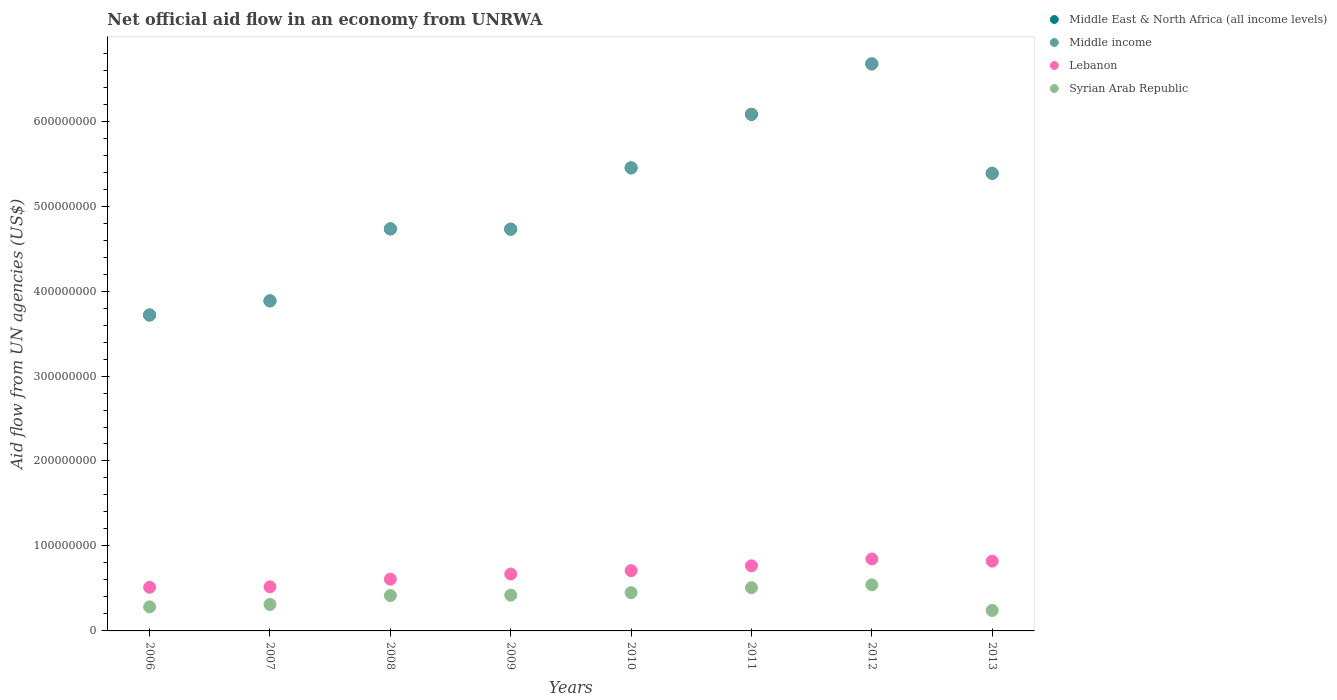Is the number of dotlines equal to the number of legend labels?
Provide a succinct answer. Yes. What is the net official aid flow in Middle East & North Africa (all income levels) in 2011?
Ensure brevity in your answer.  6.08e+08. Across all years, what is the maximum net official aid flow in Lebanon?
Ensure brevity in your answer.  8.47e+07. Across all years, what is the minimum net official aid flow in Syrian Arab Republic?
Your answer should be compact. 2.41e+07. What is the total net official aid flow in Lebanon in the graph?
Your answer should be very brief. 5.46e+08. What is the difference between the net official aid flow in Syrian Arab Republic in 2006 and that in 2011?
Your answer should be very brief. -2.26e+07. What is the difference between the net official aid flow in Middle East & North Africa (all income levels) in 2007 and the net official aid flow in Syrian Arab Republic in 2008?
Offer a very short reply. 3.47e+08. What is the average net official aid flow in Middle East & North Africa (all income levels) per year?
Offer a very short reply. 5.08e+08. In the year 2013, what is the difference between the net official aid flow in Lebanon and net official aid flow in Middle East & North Africa (all income levels)?
Give a very brief answer. -4.57e+08. In how many years, is the net official aid flow in Lebanon greater than 260000000 US$?
Your answer should be very brief. 0. What is the ratio of the net official aid flow in Middle income in 2010 to that in 2011?
Your response must be concise. 0.9. Is the difference between the net official aid flow in Lebanon in 2010 and 2011 greater than the difference between the net official aid flow in Middle East & North Africa (all income levels) in 2010 and 2011?
Your response must be concise. Yes. What is the difference between the highest and the second highest net official aid flow in Middle East & North Africa (all income levels)?
Offer a very short reply. 5.94e+07. What is the difference between the highest and the lowest net official aid flow in Syrian Arab Republic?
Offer a terse response. 3.02e+07. Is it the case that in every year, the sum of the net official aid flow in Middle East & North Africa (all income levels) and net official aid flow in Middle income  is greater than the net official aid flow in Syrian Arab Republic?
Keep it short and to the point. Yes. Is the net official aid flow in Middle East & North Africa (all income levels) strictly less than the net official aid flow in Lebanon over the years?
Provide a short and direct response. No. How many years are there in the graph?
Provide a short and direct response. 8. What is the difference between two consecutive major ticks on the Y-axis?
Offer a very short reply. 1.00e+08. Are the values on the major ticks of Y-axis written in scientific E-notation?
Make the answer very short. No. Does the graph contain any zero values?
Offer a terse response. No. Does the graph contain grids?
Make the answer very short. No. How many legend labels are there?
Provide a short and direct response. 4. What is the title of the graph?
Ensure brevity in your answer.  Net official aid flow in an economy from UNRWA. Does "Chile" appear as one of the legend labels in the graph?
Ensure brevity in your answer.  No. What is the label or title of the Y-axis?
Offer a terse response. Aid flow from UN agencies (US$). What is the Aid flow from UN agencies (US$) in Middle East & North Africa (all income levels) in 2006?
Your response must be concise. 3.72e+08. What is the Aid flow from UN agencies (US$) in Middle income in 2006?
Offer a very short reply. 3.72e+08. What is the Aid flow from UN agencies (US$) in Lebanon in 2006?
Ensure brevity in your answer.  5.14e+07. What is the Aid flow from UN agencies (US$) in Syrian Arab Republic in 2006?
Make the answer very short. 2.83e+07. What is the Aid flow from UN agencies (US$) in Middle East & North Africa (all income levels) in 2007?
Give a very brief answer. 3.88e+08. What is the Aid flow from UN agencies (US$) in Middle income in 2007?
Keep it short and to the point. 3.88e+08. What is the Aid flow from UN agencies (US$) of Lebanon in 2007?
Your answer should be compact. 5.19e+07. What is the Aid flow from UN agencies (US$) of Syrian Arab Republic in 2007?
Make the answer very short. 3.12e+07. What is the Aid flow from UN agencies (US$) in Middle East & North Africa (all income levels) in 2008?
Keep it short and to the point. 4.73e+08. What is the Aid flow from UN agencies (US$) of Middle income in 2008?
Provide a succinct answer. 4.73e+08. What is the Aid flow from UN agencies (US$) in Lebanon in 2008?
Ensure brevity in your answer.  6.09e+07. What is the Aid flow from UN agencies (US$) in Syrian Arab Republic in 2008?
Provide a succinct answer. 4.16e+07. What is the Aid flow from UN agencies (US$) in Middle East & North Africa (all income levels) in 2009?
Offer a terse response. 4.73e+08. What is the Aid flow from UN agencies (US$) in Middle income in 2009?
Your response must be concise. 4.73e+08. What is the Aid flow from UN agencies (US$) of Lebanon in 2009?
Give a very brief answer. 6.70e+07. What is the Aid flow from UN agencies (US$) of Syrian Arab Republic in 2009?
Make the answer very short. 4.21e+07. What is the Aid flow from UN agencies (US$) in Middle East & North Africa (all income levels) in 2010?
Your answer should be compact. 5.45e+08. What is the Aid flow from UN agencies (US$) in Middle income in 2010?
Ensure brevity in your answer.  5.45e+08. What is the Aid flow from UN agencies (US$) of Lebanon in 2010?
Ensure brevity in your answer.  7.10e+07. What is the Aid flow from UN agencies (US$) of Syrian Arab Republic in 2010?
Give a very brief answer. 4.50e+07. What is the Aid flow from UN agencies (US$) in Middle East & North Africa (all income levels) in 2011?
Your answer should be very brief. 6.08e+08. What is the Aid flow from UN agencies (US$) in Middle income in 2011?
Make the answer very short. 6.08e+08. What is the Aid flow from UN agencies (US$) in Lebanon in 2011?
Offer a very short reply. 7.66e+07. What is the Aid flow from UN agencies (US$) in Syrian Arab Republic in 2011?
Your answer should be compact. 5.09e+07. What is the Aid flow from UN agencies (US$) of Middle East & North Africa (all income levels) in 2012?
Offer a terse response. 6.67e+08. What is the Aid flow from UN agencies (US$) of Middle income in 2012?
Give a very brief answer. 6.67e+08. What is the Aid flow from UN agencies (US$) of Lebanon in 2012?
Offer a terse response. 8.47e+07. What is the Aid flow from UN agencies (US$) in Syrian Arab Republic in 2012?
Make the answer very short. 5.42e+07. What is the Aid flow from UN agencies (US$) in Middle East & North Africa (all income levels) in 2013?
Keep it short and to the point. 5.39e+08. What is the Aid flow from UN agencies (US$) of Middle income in 2013?
Provide a succinct answer. 5.39e+08. What is the Aid flow from UN agencies (US$) in Lebanon in 2013?
Give a very brief answer. 8.21e+07. What is the Aid flow from UN agencies (US$) of Syrian Arab Republic in 2013?
Provide a succinct answer. 2.41e+07. Across all years, what is the maximum Aid flow from UN agencies (US$) of Middle East & North Africa (all income levels)?
Provide a short and direct response. 6.67e+08. Across all years, what is the maximum Aid flow from UN agencies (US$) in Middle income?
Your response must be concise. 6.67e+08. Across all years, what is the maximum Aid flow from UN agencies (US$) in Lebanon?
Give a very brief answer. 8.47e+07. Across all years, what is the maximum Aid flow from UN agencies (US$) in Syrian Arab Republic?
Make the answer very short. 5.42e+07. Across all years, what is the minimum Aid flow from UN agencies (US$) of Middle East & North Africa (all income levels)?
Ensure brevity in your answer.  3.72e+08. Across all years, what is the minimum Aid flow from UN agencies (US$) of Middle income?
Give a very brief answer. 3.72e+08. Across all years, what is the minimum Aid flow from UN agencies (US$) in Lebanon?
Your response must be concise. 5.14e+07. Across all years, what is the minimum Aid flow from UN agencies (US$) of Syrian Arab Republic?
Provide a short and direct response. 2.41e+07. What is the total Aid flow from UN agencies (US$) in Middle East & North Africa (all income levels) in the graph?
Keep it short and to the point. 4.07e+09. What is the total Aid flow from UN agencies (US$) in Middle income in the graph?
Offer a terse response. 4.07e+09. What is the total Aid flow from UN agencies (US$) of Lebanon in the graph?
Offer a very short reply. 5.46e+08. What is the total Aid flow from UN agencies (US$) in Syrian Arab Republic in the graph?
Keep it short and to the point. 3.18e+08. What is the difference between the Aid flow from UN agencies (US$) in Middle East & North Africa (all income levels) in 2006 and that in 2007?
Ensure brevity in your answer.  -1.66e+07. What is the difference between the Aid flow from UN agencies (US$) of Middle income in 2006 and that in 2007?
Your response must be concise. -1.66e+07. What is the difference between the Aid flow from UN agencies (US$) in Lebanon in 2006 and that in 2007?
Offer a terse response. -5.30e+05. What is the difference between the Aid flow from UN agencies (US$) in Syrian Arab Republic in 2006 and that in 2007?
Make the answer very short. -2.83e+06. What is the difference between the Aid flow from UN agencies (US$) of Middle East & North Africa (all income levels) in 2006 and that in 2008?
Your answer should be very brief. -1.01e+08. What is the difference between the Aid flow from UN agencies (US$) in Middle income in 2006 and that in 2008?
Offer a very short reply. -1.01e+08. What is the difference between the Aid flow from UN agencies (US$) of Lebanon in 2006 and that in 2008?
Your response must be concise. -9.54e+06. What is the difference between the Aid flow from UN agencies (US$) of Syrian Arab Republic in 2006 and that in 2008?
Make the answer very short. -1.33e+07. What is the difference between the Aid flow from UN agencies (US$) of Middle East & North Africa (all income levels) in 2006 and that in 2009?
Keep it short and to the point. -1.01e+08. What is the difference between the Aid flow from UN agencies (US$) of Middle income in 2006 and that in 2009?
Offer a very short reply. -1.01e+08. What is the difference between the Aid flow from UN agencies (US$) of Lebanon in 2006 and that in 2009?
Keep it short and to the point. -1.56e+07. What is the difference between the Aid flow from UN agencies (US$) in Syrian Arab Republic in 2006 and that in 2009?
Ensure brevity in your answer.  -1.38e+07. What is the difference between the Aid flow from UN agencies (US$) of Middle East & North Africa (all income levels) in 2006 and that in 2010?
Your response must be concise. -1.73e+08. What is the difference between the Aid flow from UN agencies (US$) in Middle income in 2006 and that in 2010?
Your answer should be compact. -1.73e+08. What is the difference between the Aid flow from UN agencies (US$) in Lebanon in 2006 and that in 2010?
Your answer should be compact. -1.96e+07. What is the difference between the Aid flow from UN agencies (US$) in Syrian Arab Republic in 2006 and that in 2010?
Make the answer very short. -1.67e+07. What is the difference between the Aid flow from UN agencies (US$) of Middle East & North Africa (all income levels) in 2006 and that in 2011?
Give a very brief answer. -2.36e+08. What is the difference between the Aid flow from UN agencies (US$) in Middle income in 2006 and that in 2011?
Offer a very short reply. -2.36e+08. What is the difference between the Aid flow from UN agencies (US$) of Lebanon in 2006 and that in 2011?
Give a very brief answer. -2.53e+07. What is the difference between the Aid flow from UN agencies (US$) of Syrian Arab Republic in 2006 and that in 2011?
Offer a very short reply. -2.26e+07. What is the difference between the Aid flow from UN agencies (US$) in Middle East & North Africa (all income levels) in 2006 and that in 2012?
Give a very brief answer. -2.96e+08. What is the difference between the Aid flow from UN agencies (US$) of Middle income in 2006 and that in 2012?
Keep it short and to the point. -2.96e+08. What is the difference between the Aid flow from UN agencies (US$) of Lebanon in 2006 and that in 2012?
Make the answer very short. -3.33e+07. What is the difference between the Aid flow from UN agencies (US$) in Syrian Arab Republic in 2006 and that in 2012?
Provide a short and direct response. -2.59e+07. What is the difference between the Aid flow from UN agencies (US$) of Middle East & North Africa (all income levels) in 2006 and that in 2013?
Your response must be concise. -1.67e+08. What is the difference between the Aid flow from UN agencies (US$) of Middle income in 2006 and that in 2013?
Ensure brevity in your answer.  -1.67e+08. What is the difference between the Aid flow from UN agencies (US$) of Lebanon in 2006 and that in 2013?
Keep it short and to the point. -3.08e+07. What is the difference between the Aid flow from UN agencies (US$) of Syrian Arab Republic in 2006 and that in 2013?
Offer a terse response. 4.24e+06. What is the difference between the Aid flow from UN agencies (US$) in Middle East & North Africa (all income levels) in 2007 and that in 2008?
Your answer should be compact. -8.48e+07. What is the difference between the Aid flow from UN agencies (US$) of Middle income in 2007 and that in 2008?
Ensure brevity in your answer.  -8.48e+07. What is the difference between the Aid flow from UN agencies (US$) in Lebanon in 2007 and that in 2008?
Provide a short and direct response. -9.01e+06. What is the difference between the Aid flow from UN agencies (US$) of Syrian Arab Republic in 2007 and that in 2008?
Your answer should be compact. -1.05e+07. What is the difference between the Aid flow from UN agencies (US$) of Middle East & North Africa (all income levels) in 2007 and that in 2009?
Ensure brevity in your answer.  -8.44e+07. What is the difference between the Aid flow from UN agencies (US$) in Middle income in 2007 and that in 2009?
Offer a terse response. -8.44e+07. What is the difference between the Aid flow from UN agencies (US$) of Lebanon in 2007 and that in 2009?
Your answer should be very brief. -1.51e+07. What is the difference between the Aid flow from UN agencies (US$) of Syrian Arab Republic in 2007 and that in 2009?
Ensure brevity in your answer.  -1.10e+07. What is the difference between the Aid flow from UN agencies (US$) of Middle East & North Africa (all income levels) in 2007 and that in 2010?
Your response must be concise. -1.57e+08. What is the difference between the Aid flow from UN agencies (US$) of Middle income in 2007 and that in 2010?
Your answer should be compact. -1.57e+08. What is the difference between the Aid flow from UN agencies (US$) in Lebanon in 2007 and that in 2010?
Keep it short and to the point. -1.91e+07. What is the difference between the Aid flow from UN agencies (US$) in Syrian Arab Republic in 2007 and that in 2010?
Provide a short and direct response. -1.39e+07. What is the difference between the Aid flow from UN agencies (US$) in Middle East & North Africa (all income levels) in 2007 and that in 2011?
Ensure brevity in your answer.  -2.20e+08. What is the difference between the Aid flow from UN agencies (US$) in Middle income in 2007 and that in 2011?
Offer a terse response. -2.20e+08. What is the difference between the Aid flow from UN agencies (US$) of Lebanon in 2007 and that in 2011?
Your response must be concise. -2.47e+07. What is the difference between the Aid flow from UN agencies (US$) in Syrian Arab Republic in 2007 and that in 2011?
Provide a succinct answer. -1.98e+07. What is the difference between the Aid flow from UN agencies (US$) in Middle East & North Africa (all income levels) in 2007 and that in 2012?
Your answer should be very brief. -2.79e+08. What is the difference between the Aid flow from UN agencies (US$) in Middle income in 2007 and that in 2012?
Your response must be concise. -2.79e+08. What is the difference between the Aid flow from UN agencies (US$) in Lebanon in 2007 and that in 2012?
Make the answer very short. -3.28e+07. What is the difference between the Aid flow from UN agencies (US$) of Syrian Arab Republic in 2007 and that in 2012?
Your response must be concise. -2.31e+07. What is the difference between the Aid flow from UN agencies (US$) of Middle East & North Africa (all income levels) in 2007 and that in 2013?
Your answer should be very brief. -1.50e+08. What is the difference between the Aid flow from UN agencies (US$) in Middle income in 2007 and that in 2013?
Make the answer very short. -1.50e+08. What is the difference between the Aid flow from UN agencies (US$) of Lebanon in 2007 and that in 2013?
Offer a very short reply. -3.02e+07. What is the difference between the Aid flow from UN agencies (US$) of Syrian Arab Republic in 2007 and that in 2013?
Provide a succinct answer. 7.07e+06. What is the difference between the Aid flow from UN agencies (US$) in Middle East & North Africa (all income levels) in 2008 and that in 2009?
Give a very brief answer. 3.60e+05. What is the difference between the Aid flow from UN agencies (US$) of Lebanon in 2008 and that in 2009?
Give a very brief answer. -6.08e+06. What is the difference between the Aid flow from UN agencies (US$) of Syrian Arab Republic in 2008 and that in 2009?
Provide a short and direct response. -4.90e+05. What is the difference between the Aid flow from UN agencies (US$) in Middle East & North Africa (all income levels) in 2008 and that in 2010?
Offer a terse response. -7.18e+07. What is the difference between the Aid flow from UN agencies (US$) of Middle income in 2008 and that in 2010?
Your response must be concise. -7.18e+07. What is the difference between the Aid flow from UN agencies (US$) of Lebanon in 2008 and that in 2010?
Your answer should be compact. -1.01e+07. What is the difference between the Aid flow from UN agencies (US$) of Syrian Arab Republic in 2008 and that in 2010?
Provide a succinct answer. -3.40e+06. What is the difference between the Aid flow from UN agencies (US$) in Middle East & North Africa (all income levels) in 2008 and that in 2011?
Your answer should be very brief. -1.35e+08. What is the difference between the Aid flow from UN agencies (US$) in Middle income in 2008 and that in 2011?
Your answer should be very brief. -1.35e+08. What is the difference between the Aid flow from UN agencies (US$) of Lebanon in 2008 and that in 2011?
Provide a short and direct response. -1.57e+07. What is the difference between the Aid flow from UN agencies (US$) in Syrian Arab Republic in 2008 and that in 2011?
Keep it short and to the point. -9.26e+06. What is the difference between the Aid flow from UN agencies (US$) in Middle East & North Africa (all income levels) in 2008 and that in 2012?
Offer a terse response. -1.94e+08. What is the difference between the Aid flow from UN agencies (US$) in Middle income in 2008 and that in 2012?
Keep it short and to the point. -1.94e+08. What is the difference between the Aid flow from UN agencies (US$) of Lebanon in 2008 and that in 2012?
Make the answer very short. -2.38e+07. What is the difference between the Aid flow from UN agencies (US$) in Syrian Arab Republic in 2008 and that in 2012?
Give a very brief answer. -1.26e+07. What is the difference between the Aid flow from UN agencies (US$) of Middle East & North Africa (all income levels) in 2008 and that in 2013?
Give a very brief answer. -6.54e+07. What is the difference between the Aid flow from UN agencies (US$) in Middle income in 2008 and that in 2013?
Make the answer very short. -6.54e+07. What is the difference between the Aid flow from UN agencies (US$) in Lebanon in 2008 and that in 2013?
Ensure brevity in your answer.  -2.12e+07. What is the difference between the Aid flow from UN agencies (US$) of Syrian Arab Republic in 2008 and that in 2013?
Your answer should be very brief. 1.76e+07. What is the difference between the Aid flow from UN agencies (US$) in Middle East & North Africa (all income levels) in 2009 and that in 2010?
Keep it short and to the point. -7.21e+07. What is the difference between the Aid flow from UN agencies (US$) of Middle income in 2009 and that in 2010?
Provide a short and direct response. -7.21e+07. What is the difference between the Aid flow from UN agencies (US$) in Lebanon in 2009 and that in 2010?
Keep it short and to the point. -3.99e+06. What is the difference between the Aid flow from UN agencies (US$) in Syrian Arab Republic in 2009 and that in 2010?
Give a very brief answer. -2.91e+06. What is the difference between the Aid flow from UN agencies (US$) in Middle East & North Africa (all income levels) in 2009 and that in 2011?
Provide a short and direct response. -1.35e+08. What is the difference between the Aid flow from UN agencies (US$) in Middle income in 2009 and that in 2011?
Provide a short and direct response. -1.35e+08. What is the difference between the Aid flow from UN agencies (US$) in Lebanon in 2009 and that in 2011?
Keep it short and to the point. -9.64e+06. What is the difference between the Aid flow from UN agencies (US$) of Syrian Arab Republic in 2009 and that in 2011?
Your response must be concise. -8.77e+06. What is the difference between the Aid flow from UN agencies (US$) of Middle East & North Africa (all income levels) in 2009 and that in 2012?
Give a very brief answer. -1.95e+08. What is the difference between the Aid flow from UN agencies (US$) in Middle income in 2009 and that in 2012?
Your answer should be compact. -1.95e+08. What is the difference between the Aid flow from UN agencies (US$) of Lebanon in 2009 and that in 2012?
Your answer should be very brief. -1.77e+07. What is the difference between the Aid flow from UN agencies (US$) of Syrian Arab Republic in 2009 and that in 2012?
Provide a succinct answer. -1.21e+07. What is the difference between the Aid flow from UN agencies (US$) in Middle East & North Africa (all income levels) in 2009 and that in 2013?
Offer a very short reply. -6.58e+07. What is the difference between the Aid flow from UN agencies (US$) of Middle income in 2009 and that in 2013?
Make the answer very short. -6.58e+07. What is the difference between the Aid flow from UN agencies (US$) of Lebanon in 2009 and that in 2013?
Offer a terse response. -1.51e+07. What is the difference between the Aid flow from UN agencies (US$) of Syrian Arab Republic in 2009 and that in 2013?
Offer a terse response. 1.80e+07. What is the difference between the Aid flow from UN agencies (US$) of Middle East & North Africa (all income levels) in 2010 and that in 2011?
Your response must be concise. -6.30e+07. What is the difference between the Aid flow from UN agencies (US$) in Middle income in 2010 and that in 2011?
Your answer should be very brief. -6.30e+07. What is the difference between the Aid flow from UN agencies (US$) in Lebanon in 2010 and that in 2011?
Your answer should be compact. -5.65e+06. What is the difference between the Aid flow from UN agencies (US$) in Syrian Arab Republic in 2010 and that in 2011?
Provide a short and direct response. -5.86e+06. What is the difference between the Aid flow from UN agencies (US$) of Middle East & North Africa (all income levels) in 2010 and that in 2012?
Your response must be concise. -1.22e+08. What is the difference between the Aid flow from UN agencies (US$) of Middle income in 2010 and that in 2012?
Give a very brief answer. -1.22e+08. What is the difference between the Aid flow from UN agencies (US$) in Lebanon in 2010 and that in 2012?
Provide a succinct answer. -1.37e+07. What is the difference between the Aid flow from UN agencies (US$) in Syrian Arab Republic in 2010 and that in 2012?
Offer a terse response. -9.21e+06. What is the difference between the Aid flow from UN agencies (US$) in Middle East & North Africa (all income levels) in 2010 and that in 2013?
Offer a terse response. 6.34e+06. What is the difference between the Aid flow from UN agencies (US$) in Middle income in 2010 and that in 2013?
Ensure brevity in your answer.  6.34e+06. What is the difference between the Aid flow from UN agencies (US$) of Lebanon in 2010 and that in 2013?
Give a very brief answer. -1.11e+07. What is the difference between the Aid flow from UN agencies (US$) in Syrian Arab Republic in 2010 and that in 2013?
Your answer should be compact. 2.10e+07. What is the difference between the Aid flow from UN agencies (US$) in Middle East & North Africa (all income levels) in 2011 and that in 2012?
Your answer should be very brief. -5.94e+07. What is the difference between the Aid flow from UN agencies (US$) of Middle income in 2011 and that in 2012?
Provide a short and direct response. -5.94e+07. What is the difference between the Aid flow from UN agencies (US$) of Lebanon in 2011 and that in 2012?
Your answer should be very brief. -8.07e+06. What is the difference between the Aid flow from UN agencies (US$) in Syrian Arab Republic in 2011 and that in 2012?
Make the answer very short. -3.35e+06. What is the difference between the Aid flow from UN agencies (US$) of Middle East & North Africa (all income levels) in 2011 and that in 2013?
Provide a short and direct response. 6.93e+07. What is the difference between the Aid flow from UN agencies (US$) of Middle income in 2011 and that in 2013?
Ensure brevity in your answer.  6.93e+07. What is the difference between the Aid flow from UN agencies (US$) in Lebanon in 2011 and that in 2013?
Offer a terse response. -5.49e+06. What is the difference between the Aid flow from UN agencies (US$) in Syrian Arab Republic in 2011 and that in 2013?
Your response must be concise. 2.68e+07. What is the difference between the Aid flow from UN agencies (US$) in Middle East & North Africa (all income levels) in 2012 and that in 2013?
Give a very brief answer. 1.29e+08. What is the difference between the Aid flow from UN agencies (US$) in Middle income in 2012 and that in 2013?
Offer a very short reply. 1.29e+08. What is the difference between the Aid flow from UN agencies (US$) in Lebanon in 2012 and that in 2013?
Ensure brevity in your answer.  2.58e+06. What is the difference between the Aid flow from UN agencies (US$) in Syrian Arab Republic in 2012 and that in 2013?
Your response must be concise. 3.02e+07. What is the difference between the Aid flow from UN agencies (US$) in Middle East & North Africa (all income levels) in 2006 and the Aid flow from UN agencies (US$) in Middle income in 2007?
Your answer should be compact. -1.66e+07. What is the difference between the Aid flow from UN agencies (US$) in Middle East & North Africa (all income levels) in 2006 and the Aid flow from UN agencies (US$) in Lebanon in 2007?
Your response must be concise. 3.20e+08. What is the difference between the Aid flow from UN agencies (US$) in Middle East & North Africa (all income levels) in 2006 and the Aid flow from UN agencies (US$) in Syrian Arab Republic in 2007?
Your response must be concise. 3.41e+08. What is the difference between the Aid flow from UN agencies (US$) in Middle income in 2006 and the Aid flow from UN agencies (US$) in Lebanon in 2007?
Your answer should be very brief. 3.20e+08. What is the difference between the Aid flow from UN agencies (US$) in Middle income in 2006 and the Aid flow from UN agencies (US$) in Syrian Arab Republic in 2007?
Provide a short and direct response. 3.41e+08. What is the difference between the Aid flow from UN agencies (US$) in Lebanon in 2006 and the Aid flow from UN agencies (US$) in Syrian Arab Republic in 2007?
Your answer should be compact. 2.02e+07. What is the difference between the Aid flow from UN agencies (US$) in Middle East & North Africa (all income levels) in 2006 and the Aid flow from UN agencies (US$) in Middle income in 2008?
Provide a succinct answer. -1.01e+08. What is the difference between the Aid flow from UN agencies (US$) in Middle East & North Africa (all income levels) in 2006 and the Aid flow from UN agencies (US$) in Lebanon in 2008?
Your response must be concise. 3.11e+08. What is the difference between the Aid flow from UN agencies (US$) in Middle East & North Africa (all income levels) in 2006 and the Aid flow from UN agencies (US$) in Syrian Arab Republic in 2008?
Your answer should be compact. 3.30e+08. What is the difference between the Aid flow from UN agencies (US$) in Middle income in 2006 and the Aid flow from UN agencies (US$) in Lebanon in 2008?
Offer a very short reply. 3.11e+08. What is the difference between the Aid flow from UN agencies (US$) of Middle income in 2006 and the Aid flow from UN agencies (US$) of Syrian Arab Republic in 2008?
Provide a succinct answer. 3.30e+08. What is the difference between the Aid flow from UN agencies (US$) of Lebanon in 2006 and the Aid flow from UN agencies (US$) of Syrian Arab Republic in 2008?
Provide a succinct answer. 9.72e+06. What is the difference between the Aid flow from UN agencies (US$) of Middle East & North Africa (all income levels) in 2006 and the Aid flow from UN agencies (US$) of Middle income in 2009?
Offer a very short reply. -1.01e+08. What is the difference between the Aid flow from UN agencies (US$) of Middle East & North Africa (all income levels) in 2006 and the Aid flow from UN agencies (US$) of Lebanon in 2009?
Your response must be concise. 3.05e+08. What is the difference between the Aid flow from UN agencies (US$) of Middle East & North Africa (all income levels) in 2006 and the Aid flow from UN agencies (US$) of Syrian Arab Republic in 2009?
Keep it short and to the point. 3.30e+08. What is the difference between the Aid flow from UN agencies (US$) in Middle income in 2006 and the Aid flow from UN agencies (US$) in Lebanon in 2009?
Your answer should be very brief. 3.05e+08. What is the difference between the Aid flow from UN agencies (US$) of Middle income in 2006 and the Aid flow from UN agencies (US$) of Syrian Arab Republic in 2009?
Give a very brief answer. 3.30e+08. What is the difference between the Aid flow from UN agencies (US$) in Lebanon in 2006 and the Aid flow from UN agencies (US$) in Syrian Arab Republic in 2009?
Your response must be concise. 9.23e+06. What is the difference between the Aid flow from UN agencies (US$) of Middle East & North Africa (all income levels) in 2006 and the Aid flow from UN agencies (US$) of Middle income in 2010?
Provide a short and direct response. -1.73e+08. What is the difference between the Aid flow from UN agencies (US$) in Middle East & North Africa (all income levels) in 2006 and the Aid flow from UN agencies (US$) in Lebanon in 2010?
Make the answer very short. 3.01e+08. What is the difference between the Aid flow from UN agencies (US$) in Middle East & North Africa (all income levels) in 2006 and the Aid flow from UN agencies (US$) in Syrian Arab Republic in 2010?
Make the answer very short. 3.27e+08. What is the difference between the Aid flow from UN agencies (US$) in Middle income in 2006 and the Aid flow from UN agencies (US$) in Lebanon in 2010?
Provide a succinct answer. 3.01e+08. What is the difference between the Aid flow from UN agencies (US$) of Middle income in 2006 and the Aid flow from UN agencies (US$) of Syrian Arab Republic in 2010?
Your answer should be very brief. 3.27e+08. What is the difference between the Aid flow from UN agencies (US$) of Lebanon in 2006 and the Aid flow from UN agencies (US$) of Syrian Arab Republic in 2010?
Your answer should be very brief. 6.32e+06. What is the difference between the Aid flow from UN agencies (US$) in Middle East & North Africa (all income levels) in 2006 and the Aid flow from UN agencies (US$) in Middle income in 2011?
Provide a short and direct response. -2.36e+08. What is the difference between the Aid flow from UN agencies (US$) of Middle East & North Africa (all income levels) in 2006 and the Aid flow from UN agencies (US$) of Lebanon in 2011?
Provide a succinct answer. 2.95e+08. What is the difference between the Aid flow from UN agencies (US$) in Middle East & North Africa (all income levels) in 2006 and the Aid flow from UN agencies (US$) in Syrian Arab Republic in 2011?
Keep it short and to the point. 3.21e+08. What is the difference between the Aid flow from UN agencies (US$) of Middle income in 2006 and the Aid flow from UN agencies (US$) of Lebanon in 2011?
Keep it short and to the point. 2.95e+08. What is the difference between the Aid flow from UN agencies (US$) of Middle income in 2006 and the Aid flow from UN agencies (US$) of Syrian Arab Republic in 2011?
Offer a terse response. 3.21e+08. What is the difference between the Aid flow from UN agencies (US$) of Middle East & North Africa (all income levels) in 2006 and the Aid flow from UN agencies (US$) of Middle income in 2012?
Your answer should be very brief. -2.96e+08. What is the difference between the Aid flow from UN agencies (US$) of Middle East & North Africa (all income levels) in 2006 and the Aid flow from UN agencies (US$) of Lebanon in 2012?
Give a very brief answer. 2.87e+08. What is the difference between the Aid flow from UN agencies (US$) in Middle East & North Africa (all income levels) in 2006 and the Aid flow from UN agencies (US$) in Syrian Arab Republic in 2012?
Make the answer very short. 3.18e+08. What is the difference between the Aid flow from UN agencies (US$) in Middle income in 2006 and the Aid flow from UN agencies (US$) in Lebanon in 2012?
Give a very brief answer. 2.87e+08. What is the difference between the Aid flow from UN agencies (US$) of Middle income in 2006 and the Aid flow from UN agencies (US$) of Syrian Arab Republic in 2012?
Offer a terse response. 3.18e+08. What is the difference between the Aid flow from UN agencies (US$) of Lebanon in 2006 and the Aid flow from UN agencies (US$) of Syrian Arab Republic in 2012?
Your answer should be very brief. -2.89e+06. What is the difference between the Aid flow from UN agencies (US$) of Middle East & North Africa (all income levels) in 2006 and the Aid flow from UN agencies (US$) of Middle income in 2013?
Provide a succinct answer. -1.67e+08. What is the difference between the Aid flow from UN agencies (US$) of Middle East & North Africa (all income levels) in 2006 and the Aid flow from UN agencies (US$) of Lebanon in 2013?
Ensure brevity in your answer.  2.90e+08. What is the difference between the Aid flow from UN agencies (US$) in Middle East & North Africa (all income levels) in 2006 and the Aid flow from UN agencies (US$) in Syrian Arab Republic in 2013?
Provide a short and direct response. 3.48e+08. What is the difference between the Aid flow from UN agencies (US$) of Middle income in 2006 and the Aid flow from UN agencies (US$) of Lebanon in 2013?
Offer a terse response. 2.90e+08. What is the difference between the Aid flow from UN agencies (US$) of Middle income in 2006 and the Aid flow from UN agencies (US$) of Syrian Arab Republic in 2013?
Your answer should be compact. 3.48e+08. What is the difference between the Aid flow from UN agencies (US$) in Lebanon in 2006 and the Aid flow from UN agencies (US$) in Syrian Arab Republic in 2013?
Your answer should be compact. 2.73e+07. What is the difference between the Aid flow from UN agencies (US$) of Middle East & North Africa (all income levels) in 2007 and the Aid flow from UN agencies (US$) of Middle income in 2008?
Keep it short and to the point. -8.48e+07. What is the difference between the Aid flow from UN agencies (US$) of Middle East & North Africa (all income levels) in 2007 and the Aid flow from UN agencies (US$) of Lebanon in 2008?
Provide a succinct answer. 3.28e+08. What is the difference between the Aid flow from UN agencies (US$) of Middle East & North Africa (all income levels) in 2007 and the Aid flow from UN agencies (US$) of Syrian Arab Republic in 2008?
Your response must be concise. 3.47e+08. What is the difference between the Aid flow from UN agencies (US$) in Middle income in 2007 and the Aid flow from UN agencies (US$) in Lebanon in 2008?
Your answer should be very brief. 3.28e+08. What is the difference between the Aid flow from UN agencies (US$) in Middle income in 2007 and the Aid flow from UN agencies (US$) in Syrian Arab Republic in 2008?
Your response must be concise. 3.47e+08. What is the difference between the Aid flow from UN agencies (US$) in Lebanon in 2007 and the Aid flow from UN agencies (US$) in Syrian Arab Republic in 2008?
Make the answer very short. 1.02e+07. What is the difference between the Aid flow from UN agencies (US$) in Middle East & North Africa (all income levels) in 2007 and the Aid flow from UN agencies (US$) in Middle income in 2009?
Your answer should be compact. -8.44e+07. What is the difference between the Aid flow from UN agencies (US$) of Middle East & North Africa (all income levels) in 2007 and the Aid flow from UN agencies (US$) of Lebanon in 2009?
Provide a short and direct response. 3.21e+08. What is the difference between the Aid flow from UN agencies (US$) of Middle East & North Africa (all income levels) in 2007 and the Aid flow from UN agencies (US$) of Syrian Arab Republic in 2009?
Give a very brief answer. 3.46e+08. What is the difference between the Aid flow from UN agencies (US$) in Middle income in 2007 and the Aid flow from UN agencies (US$) in Lebanon in 2009?
Provide a succinct answer. 3.21e+08. What is the difference between the Aid flow from UN agencies (US$) in Middle income in 2007 and the Aid flow from UN agencies (US$) in Syrian Arab Republic in 2009?
Your answer should be compact. 3.46e+08. What is the difference between the Aid flow from UN agencies (US$) in Lebanon in 2007 and the Aid flow from UN agencies (US$) in Syrian Arab Republic in 2009?
Offer a terse response. 9.76e+06. What is the difference between the Aid flow from UN agencies (US$) of Middle East & North Africa (all income levels) in 2007 and the Aid flow from UN agencies (US$) of Middle income in 2010?
Give a very brief answer. -1.57e+08. What is the difference between the Aid flow from UN agencies (US$) in Middle East & North Africa (all income levels) in 2007 and the Aid flow from UN agencies (US$) in Lebanon in 2010?
Offer a very short reply. 3.17e+08. What is the difference between the Aid flow from UN agencies (US$) of Middle East & North Africa (all income levels) in 2007 and the Aid flow from UN agencies (US$) of Syrian Arab Republic in 2010?
Provide a short and direct response. 3.43e+08. What is the difference between the Aid flow from UN agencies (US$) of Middle income in 2007 and the Aid flow from UN agencies (US$) of Lebanon in 2010?
Offer a very short reply. 3.17e+08. What is the difference between the Aid flow from UN agencies (US$) of Middle income in 2007 and the Aid flow from UN agencies (US$) of Syrian Arab Republic in 2010?
Make the answer very short. 3.43e+08. What is the difference between the Aid flow from UN agencies (US$) in Lebanon in 2007 and the Aid flow from UN agencies (US$) in Syrian Arab Republic in 2010?
Offer a terse response. 6.85e+06. What is the difference between the Aid flow from UN agencies (US$) in Middle East & North Africa (all income levels) in 2007 and the Aid flow from UN agencies (US$) in Middle income in 2011?
Offer a terse response. -2.20e+08. What is the difference between the Aid flow from UN agencies (US$) of Middle East & North Africa (all income levels) in 2007 and the Aid flow from UN agencies (US$) of Lebanon in 2011?
Keep it short and to the point. 3.12e+08. What is the difference between the Aid flow from UN agencies (US$) of Middle East & North Africa (all income levels) in 2007 and the Aid flow from UN agencies (US$) of Syrian Arab Republic in 2011?
Your response must be concise. 3.38e+08. What is the difference between the Aid flow from UN agencies (US$) of Middle income in 2007 and the Aid flow from UN agencies (US$) of Lebanon in 2011?
Keep it short and to the point. 3.12e+08. What is the difference between the Aid flow from UN agencies (US$) in Middle income in 2007 and the Aid flow from UN agencies (US$) in Syrian Arab Republic in 2011?
Ensure brevity in your answer.  3.38e+08. What is the difference between the Aid flow from UN agencies (US$) of Lebanon in 2007 and the Aid flow from UN agencies (US$) of Syrian Arab Republic in 2011?
Your answer should be compact. 9.90e+05. What is the difference between the Aid flow from UN agencies (US$) in Middle East & North Africa (all income levels) in 2007 and the Aid flow from UN agencies (US$) in Middle income in 2012?
Ensure brevity in your answer.  -2.79e+08. What is the difference between the Aid flow from UN agencies (US$) in Middle East & North Africa (all income levels) in 2007 and the Aid flow from UN agencies (US$) in Lebanon in 2012?
Offer a terse response. 3.04e+08. What is the difference between the Aid flow from UN agencies (US$) of Middle East & North Africa (all income levels) in 2007 and the Aid flow from UN agencies (US$) of Syrian Arab Republic in 2012?
Offer a very short reply. 3.34e+08. What is the difference between the Aid flow from UN agencies (US$) of Middle income in 2007 and the Aid flow from UN agencies (US$) of Lebanon in 2012?
Keep it short and to the point. 3.04e+08. What is the difference between the Aid flow from UN agencies (US$) in Middle income in 2007 and the Aid flow from UN agencies (US$) in Syrian Arab Republic in 2012?
Offer a terse response. 3.34e+08. What is the difference between the Aid flow from UN agencies (US$) of Lebanon in 2007 and the Aid flow from UN agencies (US$) of Syrian Arab Republic in 2012?
Ensure brevity in your answer.  -2.36e+06. What is the difference between the Aid flow from UN agencies (US$) in Middle East & North Africa (all income levels) in 2007 and the Aid flow from UN agencies (US$) in Middle income in 2013?
Offer a very short reply. -1.50e+08. What is the difference between the Aid flow from UN agencies (US$) of Middle East & North Africa (all income levels) in 2007 and the Aid flow from UN agencies (US$) of Lebanon in 2013?
Keep it short and to the point. 3.06e+08. What is the difference between the Aid flow from UN agencies (US$) in Middle East & North Africa (all income levels) in 2007 and the Aid flow from UN agencies (US$) in Syrian Arab Republic in 2013?
Offer a terse response. 3.64e+08. What is the difference between the Aid flow from UN agencies (US$) in Middle income in 2007 and the Aid flow from UN agencies (US$) in Lebanon in 2013?
Make the answer very short. 3.06e+08. What is the difference between the Aid flow from UN agencies (US$) in Middle income in 2007 and the Aid flow from UN agencies (US$) in Syrian Arab Republic in 2013?
Ensure brevity in your answer.  3.64e+08. What is the difference between the Aid flow from UN agencies (US$) in Lebanon in 2007 and the Aid flow from UN agencies (US$) in Syrian Arab Republic in 2013?
Keep it short and to the point. 2.78e+07. What is the difference between the Aid flow from UN agencies (US$) in Middle East & North Africa (all income levels) in 2008 and the Aid flow from UN agencies (US$) in Middle income in 2009?
Offer a terse response. 3.60e+05. What is the difference between the Aid flow from UN agencies (US$) in Middle East & North Africa (all income levels) in 2008 and the Aid flow from UN agencies (US$) in Lebanon in 2009?
Your response must be concise. 4.06e+08. What is the difference between the Aid flow from UN agencies (US$) in Middle East & North Africa (all income levels) in 2008 and the Aid flow from UN agencies (US$) in Syrian Arab Republic in 2009?
Offer a very short reply. 4.31e+08. What is the difference between the Aid flow from UN agencies (US$) of Middle income in 2008 and the Aid flow from UN agencies (US$) of Lebanon in 2009?
Ensure brevity in your answer.  4.06e+08. What is the difference between the Aid flow from UN agencies (US$) of Middle income in 2008 and the Aid flow from UN agencies (US$) of Syrian Arab Republic in 2009?
Your answer should be very brief. 4.31e+08. What is the difference between the Aid flow from UN agencies (US$) of Lebanon in 2008 and the Aid flow from UN agencies (US$) of Syrian Arab Republic in 2009?
Your response must be concise. 1.88e+07. What is the difference between the Aid flow from UN agencies (US$) of Middle East & North Africa (all income levels) in 2008 and the Aid flow from UN agencies (US$) of Middle income in 2010?
Provide a short and direct response. -7.18e+07. What is the difference between the Aid flow from UN agencies (US$) in Middle East & North Africa (all income levels) in 2008 and the Aid flow from UN agencies (US$) in Lebanon in 2010?
Provide a succinct answer. 4.02e+08. What is the difference between the Aid flow from UN agencies (US$) of Middle East & North Africa (all income levels) in 2008 and the Aid flow from UN agencies (US$) of Syrian Arab Republic in 2010?
Your response must be concise. 4.28e+08. What is the difference between the Aid flow from UN agencies (US$) of Middle income in 2008 and the Aid flow from UN agencies (US$) of Lebanon in 2010?
Make the answer very short. 4.02e+08. What is the difference between the Aid flow from UN agencies (US$) of Middle income in 2008 and the Aid flow from UN agencies (US$) of Syrian Arab Republic in 2010?
Offer a very short reply. 4.28e+08. What is the difference between the Aid flow from UN agencies (US$) of Lebanon in 2008 and the Aid flow from UN agencies (US$) of Syrian Arab Republic in 2010?
Ensure brevity in your answer.  1.59e+07. What is the difference between the Aid flow from UN agencies (US$) of Middle East & North Africa (all income levels) in 2008 and the Aid flow from UN agencies (US$) of Middle income in 2011?
Ensure brevity in your answer.  -1.35e+08. What is the difference between the Aid flow from UN agencies (US$) in Middle East & North Africa (all income levels) in 2008 and the Aid flow from UN agencies (US$) in Lebanon in 2011?
Make the answer very short. 3.97e+08. What is the difference between the Aid flow from UN agencies (US$) in Middle East & North Africa (all income levels) in 2008 and the Aid flow from UN agencies (US$) in Syrian Arab Republic in 2011?
Give a very brief answer. 4.22e+08. What is the difference between the Aid flow from UN agencies (US$) of Middle income in 2008 and the Aid flow from UN agencies (US$) of Lebanon in 2011?
Your answer should be compact. 3.97e+08. What is the difference between the Aid flow from UN agencies (US$) of Middle income in 2008 and the Aid flow from UN agencies (US$) of Syrian Arab Republic in 2011?
Your answer should be very brief. 4.22e+08. What is the difference between the Aid flow from UN agencies (US$) of Middle East & North Africa (all income levels) in 2008 and the Aid flow from UN agencies (US$) of Middle income in 2012?
Offer a terse response. -1.94e+08. What is the difference between the Aid flow from UN agencies (US$) of Middle East & North Africa (all income levels) in 2008 and the Aid flow from UN agencies (US$) of Lebanon in 2012?
Ensure brevity in your answer.  3.88e+08. What is the difference between the Aid flow from UN agencies (US$) in Middle East & North Africa (all income levels) in 2008 and the Aid flow from UN agencies (US$) in Syrian Arab Republic in 2012?
Ensure brevity in your answer.  4.19e+08. What is the difference between the Aid flow from UN agencies (US$) in Middle income in 2008 and the Aid flow from UN agencies (US$) in Lebanon in 2012?
Your answer should be compact. 3.88e+08. What is the difference between the Aid flow from UN agencies (US$) in Middle income in 2008 and the Aid flow from UN agencies (US$) in Syrian Arab Republic in 2012?
Provide a short and direct response. 4.19e+08. What is the difference between the Aid flow from UN agencies (US$) in Lebanon in 2008 and the Aid flow from UN agencies (US$) in Syrian Arab Republic in 2012?
Provide a short and direct response. 6.65e+06. What is the difference between the Aid flow from UN agencies (US$) of Middle East & North Africa (all income levels) in 2008 and the Aid flow from UN agencies (US$) of Middle income in 2013?
Ensure brevity in your answer.  -6.54e+07. What is the difference between the Aid flow from UN agencies (US$) of Middle East & North Africa (all income levels) in 2008 and the Aid flow from UN agencies (US$) of Lebanon in 2013?
Your answer should be very brief. 3.91e+08. What is the difference between the Aid flow from UN agencies (US$) of Middle East & North Africa (all income levels) in 2008 and the Aid flow from UN agencies (US$) of Syrian Arab Republic in 2013?
Make the answer very short. 4.49e+08. What is the difference between the Aid flow from UN agencies (US$) in Middle income in 2008 and the Aid flow from UN agencies (US$) in Lebanon in 2013?
Provide a short and direct response. 3.91e+08. What is the difference between the Aid flow from UN agencies (US$) in Middle income in 2008 and the Aid flow from UN agencies (US$) in Syrian Arab Republic in 2013?
Keep it short and to the point. 4.49e+08. What is the difference between the Aid flow from UN agencies (US$) in Lebanon in 2008 and the Aid flow from UN agencies (US$) in Syrian Arab Republic in 2013?
Make the answer very short. 3.68e+07. What is the difference between the Aid flow from UN agencies (US$) of Middle East & North Africa (all income levels) in 2009 and the Aid flow from UN agencies (US$) of Middle income in 2010?
Ensure brevity in your answer.  -7.21e+07. What is the difference between the Aid flow from UN agencies (US$) in Middle East & North Africa (all income levels) in 2009 and the Aid flow from UN agencies (US$) in Lebanon in 2010?
Ensure brevity in your answer.  4.02e+08. What is the difference between the Aid flow from UN agencies (US$) in Middle East & North Africa (all income levels) in 2009 and the Aid flow from UN agencies (US$) in Syrian Arab Republic in 2010?
Provide a succinct answer. 4.28e+08. What is the difference between the Aid flow from UN agencies (US$) in Middle income in 2009 and the Aid flow from UN agencies (US$) in Lebanon in 2010?
Keep it short and to the point. 4.02e+08. What is the difference between the Aid flow from UN agencies (US$) in Middle income in 2009 and the Aid flow from UN agencies (US$) in Syrian Arab Republic in 2010?
Make the answer very short. 4.28e+08. What is the difference between the Aid flow from UN agencies (US$) of Lebanon in 2009 and the Aid flow from UN agencies (US$) of Syrian Arab Republic in 2010?
Ensure brevity in your answer.  2.19e+07. What is the difference between the Aid flow from UN agencies (US$) in Middle East & North Africa (all income levels) in 2009 and the Aid flow from UN agencies (US$) in Middle income in 2011?
Make the answer very short. -1.35e+08. What is the difference between the Aid flow from UN agencies (US$) of Middle East & North Africa (all income levels) in 2009 and the Aid flow from UN agencies (US$) of Lebanon in 2011?
Ensure brevity in your answer.  3.96e+08. What is the difference between the Aid flow from UN agencies (US$) of Middle East & North Africa (all income levels) in 2009 and the Aid flow from UN agencies (US$) of Syrian Arab Republic in 2011?
Your answer should be compact. 4.22e+08. What is the difference between the Aid flow from UN agencies (US$) of Middle income in 2009 and the Aid flow from UN agencies (US$) of Lebanon in 2011?
Keep it short and to the point. 3.96e+08. What is the difference between the Aid flow from UN agencies (US$) of Middle income in 2009 and the Aid flow from UN agencies (US$) of Syrian Arab Republic in 2011?
Your response must be concise. 4.22e+08. What is the difference between the Aid flow from UN agencies (US$) in Lebanon in 2009 and the Aid flow from UN agencies (US$) in Syrian Arab Republic in 2011?
Your answer should be compact. 1.61e+07. What is the difference between the Aid flow from UN agencies (US$) of Middle East & North Africa (all income levels) in 2009 and the Aid flow from UN agencies (US$) of Middle income in 2012?
Give a very brief answer. -1.95e+08. What is the difference between the Aid flow from UN agencies (US$) of Middle East & North Africa (all income levels) in 2009 and the Aid flow from UN agencies (US$) of Lebanon in 2012?
Provide a short and direct response. 3.88e+08. What is the difference between the Aid flow from UN agencies (US$) of Middle East & North Africa (all income levels) in 2009 and the Aid flow from UN agencies (US$) of Syrian Arab Republic in 2012?
Give a very brief answer. 4.19e+08. What is the difference between the Aid flow from UN agencies (US$) in Middle income in 2009 and the Aid flow from UN agencies (US$) in Lebanon in 2012?
Keep it short and to the point. 3.88e+08. What is the difference between the Aid flow from UN agencies (US$) in Middle income in 2009 and the Aid flow from UN agencies (US$) in Syrian Arab Republic in 2012?
Provide a short and direct response. 4.19e+08. What is the difference between the Aid flow from UN agencies (US$) in Lebanon in 2009 and the Aid flow from UN agencies (US$) in Syrian Arab Republic in 2012?
Make the answer very short. 1.27e+07. What is the difference between the Aid flow from UN agencies (US$) of Middle East & North Africa (all income levels) in 2009 and the Aid flow from UN agencies (US$) of Middle income in 2013?
Your answer should be compact. -6.58e+07. What is the difference between the Aid flow from UN agencies (US$) of Middle East & North Africa (all income levels) in 2009 and the Aid flow from UN agencies (US$) of Lebanon in 2013?
Ensure brevity in your answer.  3.91e+08. What is the difference between the Aid flow from UN agencies (US$) of Middle East & North Africa (all income levels) in 2009 and the Aid flow from UN agencies (US$) of Syrian Arab Republic in 2013?
Keep it short and to the point. 4.49e+08. What is the difference between the Aid flow from UN agencies (US$) in Middle income in 2009 and the Aid flow from UN agencies (US$) in Lebanon in 2013?
Your answer should be compact. 3.91e+08. What is the difference between the Aid flow from UN agencies (US$) of Middle income in 2009 and the Aid flow from UN agencies (US$) of Syrian Arab Republic in 2013?
Provide a short and direct response. 4.49e+08. What is the difference between the Aid flow from UN agencies (US$) in Lebanon in 2009 and the Aid flow from UN agencies (US$) in Syrian Arab Republic in 2013?
Make the answer very short. 4.29e+07. What is the difference between the Aid flow from UN agencies (US$) of Middle East & North Africa (all income levels) in 2010 and the Aid flow from UN agencies (US$) of Middle income in 2011?
Make the answer very short. -6.30e+07. What is the difference between the Aid flow from UN agencies (US$) of Middle East & North Africa (all income levels) in 2010 and the Aid flow from UN agencies (US$) of Lebanon in 2011?
Your response must be concise. 4.68e+08. What is the difference between the Aid flow from UN agencies (US$) in Middle East & North Africa (all income levels) in 2010 and the Aid flow from UN agencies (US$) in Syrian Arab Republic in 2011?
Give a very brief answer. 4.94e+08. What is the difference between the Aid flow from UN agencies (US$) of Middle income in 2010 and the Aid flow from UN agencies (US$) of Lebanon in 2011?
Your answer should be compact. 4.68e+08. What is the difference between the Aid flow from UN agencies (US$) in Middle income in 2010 and the Aid flow from UN agencies (US$) in Syrian Arab Republic in 2011?
Your answer should be very brief. 4.94e+08. What is the difference between the Aid flow from UN agencies (US$) in Lebanon in 2010 and the Aid flow from UN agencies (US$) in Syrian Arab Republic in 2011?
Ensure brevity in your answer.  2.01e+07. What is the difference between the Aid flow from UN agencies (US$) of Middle East & North Africa (all income levels) in 2010 and the Aid flow from UN agencies (US$) of Middle income in 2012?
Offer a terse response. -1.22e+08. What is the difference between the Aid flow from UN agencies (US$) of Middle East & North Africa (all income levels) in 2010 and the Aid flow from UN agencies (US$) of Lebanon in 2012?
Make the answer very short. 4.60e+08. What is the difference between the Aid flow from UN agencies (US$) of Middle East & North Africa (all income levels) in 2010 and the Aid flow from UN agencies (US$) of Syrian Arab Republic in 2012?
Ensure brevity in your answer.  4.91e+08. What is the difference between the Aid flow from UN agencies (US$) in Middle income in 2010 and the Aid flow from UN agencies (US$) in Lebanon in 2012?
Make the answer very short. 4.60e+08. What is the difference between the Aid flow from UN agencies (US$) of Middle income in 2010 and the Aid flow from UN agencies (US$) of Syrian Arab Republic in 2012?
Offer a terse response. 4.91e+08. What is the difference between the Aid flow from UN agencies (US$) of Lebanon in 2010 and the Aid flow from UN agencies (US$) of Syrian Arab Republic in 2012?
Provide a short and direct response. 1.67e+07. What is the difference between the Aid flow from UN agencies (US$) of Middle East & North Africa (all income levels) in 2010 and the Aid flow from UN agencies (US$) of Middle income in 2013?
Give a very brief answer. 6.34e+06. What is the difference between the Aid flow from UN agencies (US$) of Middle East & North Africa (all income levels) in 2010 and the Aid flow from UN agencies (US$) of Lebanon in 2013?
Provide a succinct answer. 4.63e+08. What is the difference between the Aid flow from UN agencies (US$) in Middle East & North Africa (all income levels) in 2010 and the Aid flow from UN agencies (US$) in Syrian Arab Republic in 2013?
Provide a succinct answer. 5.21e+08. What is the difference between the Aid flow from UN agencies (US$) of Middle income in 2010 and the Aid flow from UN agencies (US$) of Lebanon in 2013?
Your answer should be compact. 4.63e+08. What is the difference between the Aid flow from UN agencies (US$) of Middle income in 2010 and the Aid flow from UN agencies (US$) of Syrian Arab Republic in 2013?
Offer a very short reply. 5.21e+08. What is the difference between the Aid flow from UN agencies (US$) in Lebanon in 2010 and the Aid flow from UN agencies (US$) in Syrian Arab Republic in 2013?
Ensure brevity in your answer.  4.69e+07. What is the difference between the Aid flow from UN agencies (US$) in Middle East & North Africa (all income levels) in 2011 and the Aid flow from UN agencies (US$) in Middle income in 2012?
Make the answer very short. -5.94e+07. What is the difference between the Aid flow from UN agencies (US$) of Middle East & North Africa (all income levels) in 2011 and the Aid flow from UN agencies (US$) of Lebanon in 2012?
Your answer should be compact. 5.23e+08. What is the difference between the Aid flow from UN agencies (US$) in Middle East & North Africa (all income levels) in 2011 and the Aid flow from UN agencies (US$) in Syrian Arab Republic in 2012?
Provide a succinct answer. 5.54e+08. What is the difference between the Aid flow from UN agencies (US$) of Middle income in 2011 and the Aid flow from UN agencies (US$) of Lebanon in 2012?
Make the answer very short. 5.23e+08. What is the difference between the Aid flow from UN agencies (US$) of Middle income in 2011 and the Aid flow from UN agencies (US$) of Syrian Arab Republic in 2012?
Offer a very short reply. 5.54e+08. What is the difference between the Aid flow from UN agencies (US$) in Lebanon in 2011 and the Aid flow from UN agencies (US$) in Syrian Arab Republic in 2012?
Provide a succinct answer. 2.24e+07. What is the difference between the Aid flow from UN agencies (US$) of Middle East & North Africa (all income levels) in 2011 and the Aid flow from UN agencies (US$) of Middle income in 2013?
Offer a very short reply. 6.93e+07. What is the difference between the Aid flow from UN agencies (US$) in Middle East & North Africa (all income levels) in 2011 and the Aid flow from UN agencies (US$) in Lebanon in 2013?
Give a very brief answer. 5.26e+08. What is the difference between the Aid flow from UN agencies (US$) of Middle East & North Africa (all income levels) in 2011 and the Aid flow from UN agencies (US$) of Syrian Arab Republic in 2013?
Your response must be concise. 5.84e+08. What is the difference between the Aid flow from UN agencies (US$) of Middle income in 2011 and the Aid flow from UN agencies (US$) of Lebanon in 2013?
Your response must be concise. 5.26e+08. What is the difference between the Aid flow from UN agencies (US$) in Middle income in 2011 and the Aid flow from UN agencies (US$) in Syrian Arab Republic in 2013?
Offer a very short reply. 5.84e+08. What is the difference between the Aid flow from UN agencies (US$) of Lebanon in 2011 and the Aid flow from UN agencies (US$) of Syrian Arab Republic in 2013?
Your answer should be compact. 5.25e+07. What is the difference between the Aid flow from UN agencies (US$) of Middle East & North Africa (all income levels) in 2012 and the Aid flow from UN agencies (US$) of Middle income in 2013?
Keep it short and to the point. 1.29e+08. What is the difference between the Aid flow from UN agencies (US$) in Middle East & North Africa (all income levels) in 2012 and the Aid flow from UN agencies (US$) in Lebanon in 2013?
Your response must be concise. 5.85e+08. What is the difference between the Aid flow from UN agencies (US$) of Middle East & North Africa (all income levels) in 2012 and the Aid flow from UN agencies (US$) of Syrian Arab Republic in 2013?
Your response must be concise. 6.43e+08. What is the difference between the Aid flow from UN agencies (US$) in Middle income in 2012 and the Aid flow from UN agencies (US$) in Lebanon in 2013?
Offer a terse response. 5.85e+08. What is the difference between the Aid flow from UN agencies (US$) in Middle income in 2012 and the Aid flow from UN agencies (US$) in Syrian Arab Republic in 2013?
Ensure brevity in your answer.  6.43e+08. What is the difference between the Aid flow from UN agencies (US$) of Lebanon in 2012 and the Aid flow from UN agencies (US$) of Syrian Arab Republic in 2013?
Give a very brief answer. 6.06e+07. What is the average Aid flow from UN agencies (US$) in Middle East & North Africa (all income levels) per year?
Your response must be concise. 5.08e+08. What is the average Aid flow from UN agencies (US$) of Middle income per year?
Make the answer very short. 5.08e+08. What is the average Aid flow from UN agencies (US$) of Lebanon per year?
Keep it short and to the point. 6.82e+07. What is the average Aid flow from UN agencies (US$) in Syrian Arab Republic per year?
Give a very brief answer. 3.97e+07. In the year 2006, what is the difference between the Aid flow from UN agencies (US$) of Middle East & North Africa (all income levels) and Aid flow from UN agencies (US$) of Middle income?
Make the answer very short. 0. In the year 2006, what is the difference between the Aid flow from UN agencies (US$) in Middle East & North Africa (all income levels) and Aid flow from UN agencies (US$) in Lebanon?
Provide a succinct answer. 3.20e+08. In the year 2006, what is the difference between the Aid flow from UN agencies (US$) in Middle East & North Africa (all income levels) and Aid flow from UN agencies (US$) in Syrian Arab Republic?
Make the answer very short. 3.43e+08. In the year 2006, what is the difference between the Aid flow from UN agencies (US$) in Middle income and Aid flow from UN agencies (US$) in Lebanon?
Provide a succinct answer. 3.20e+08. In the year 2006, what is the difference between the Aid flow from UN agencies (US$) in Middle income and Aid flow from UN agencies (US$) in Syrian Arab Republic?
Keep it short and to the point. 3.43e+08. In the year 2006, what is the difference between the Aid flow from UN agencies (US$) of Lebanon and Aid flow from UN agencies (US$) of Syrian Arab Republic?
Make the answer very short. 2.30e+07. In the year 2007, what is the difference between the Aid flow from UN agencies (US$) of Middle East & North Africa (all income levels) and Aid flow from UN agencies (US$) of Lebanon?
Give a very brief answer. 3.37e+08. In the year 2007, what is the difference between the Aid flow from UN agencies (US$) of Middle East & North Africa (all income levels) and Aid flow from UN agencies (US$) of Syrian Arab Republic?
Your answer should be very brief. 3.57e+08. In the year 2007, what is the difference between the Aid flow from UN agencies (US$) in Middle income and Aid flow from UN agencies (US$) in Lebanon?
Your response must be concise. 3.37e+08. In the year 2007, what is the difference between the Aid flow from UN agencies (US$) of Middle income and Aid flow from UN agencies (US$) of Syrian Arab Republic?
Ensure brevity in your answer.  3.57e+08. In the year 2007, what is the difference between the Aid flow from UN agencies (US$) in Lebanon and Aid flow from UN agencies (US$) in Syrian Arab Republic?
Give a very brief answer. 2.07e+07. In the year 2008, what is the difference between the Aid flow from UN agencies (US$) of Middle East & North Africa (all income levels) and Aid flow from UN agencies (US$) of Middle income?
Keep it short and to the point. 0. In the year 2008, what is the difference between the Aid flow from UN agencies (US$) in Middle East & North Africa (all income levels) and Aid flow from UN agencies (US$) in Lebanon?
Your response must be concise. 4.12e+08. In the year 2008, what is the difference between the Aid flow from UN agencies (US$) in Middle East & North Africa (all income levels) and Aid flow from UN agencies (US$) in Syrian Arab Republic?
Provide a short and direct response. 4.32e+08. In the year 2008, what is the difference between the Aid flow from UN agencies (US$) of Middle income and Aid flow from UN agencies (US$) of Lebanon?
Offer a very short reply. 4.12e+08. In the year 2008, what is the difference between the Aid flow from UN agencies (US$) in Middle income and Aid flow from UN agencies (US$) in Syrian Arab Republic?
Your answer should be very brief. 4.32e+08. In the year 2008, what is the difference between the Aid flow from UN agencies (US$) in Lebanon and Aid flow from UN agencies (US$) in Syrian Arab Republic?
Give a very brief answer. 1.93e+07. In the year 2009, what is the difference between the Aid flow from UN agencies (US$) of Middle East & North Africa (all income levels) and Aid flow from UN agencies (US$) of Lebanon?
Your answer should be very brief. 4.06e+08. In the year 2009, what is the difference between the Aid flow from UN agencies (US$) of Middle East & North Africa (all income levels) and Aid flow from UN agencies (US$) of Syrian Arab Republic?
Keep it short and to the point. 4.31e+08. In the year 2009, what is the difference between the Aid flow from UN agencies (US$) in Middle income and Aid flow from UN agencies (US$) in Lebanon?
Provide a short and direct response. 4.06e+08. In the year 2009, what is the difference between the Aid flow from UN agencies (US$) of Middle income and Aid flow from UN agencies (US$) of Syrian Arab Republic?
Provide a short and direct response. 4.31e+08. In the year 2009, what is the difference between the Aid flow from UN agencies (US$) in Lebanon and Aid flow from UN agencies (US$) in Syrian Arab Republic?
Provide a succinct answer. 2.48e+07. In the year 2010, what is the difference between the Aid flow from UN agencies (US$) in Middle East & North Africa (all income levels) and Aid flow from UN agencies (US$) in Lebanon?
Offer a terse response. 4.74e+08. In the year 2010, what is the difference between the Aid flow from UN agencies (US$) of Middle East & North Africa (all income levels) and Aid flow from UN agencies (US$) of Syrian Arab Republic?
Offer a very short reply. 5.00e+08. In the year 2010, what is the difference between the Aid flow from UN agencies (US$) in Middle income and Aid flow from UN agencies (US$) in Lebanon?
Provide a succinct answer. 4.74e+08. In the year 2010, what is the difference between the Aid flow from UN agencies (US$) of Middle income and Aid flow from UN agencies (US$) of Syrian Arab Republic?
Provide a short and direct response. 5.00e+08. In the year 2010, what is the difference between the Aid flow from UN agencies (US$) of Lebanon and Aid flow from UN agencies (US$) of Syrian Arab Republic?
Offer a terse response. 2.59e+07. In the year 2011, what is the difference between the Aid flow from UN agencies (US$) of Middle East & North Africa (all income levels) and Aid flow from UN agencies (US$) of Lebanon?
Offer a very short reply. 5.31e+08. In the year 2011, what is the difference between the Aid flow from UN agencies (US$) in Middle East & North Africa (all income levels) and Aid flow from UN agencies (US$) in Syrian Arab Republic?
Provide a short and direct response. 5.57e+08. In the year 2011, what is the difference between the Aid flow from UN agencies (US$) of Middle income and Aid flow from UN agencies (US$) of Lebanon?
Ensure brevity in your answer.  5.31e+08. In the year 2011, what is the difference between the Aid flow from UN agencies (US$) of Middle income and Aid flow from UN agencies (US$) of Syrian Arab Republic?
Make the answer very short. 5.57e+08. In the year 2011, what is the difference between the Aid flow from UN agencies (US$) of Lebanon and Aid flow from UN agencies (US$) of Syrian Arab Republic?
Your answer should be compact. 2.57e+07. In the year 2012, what is the difference between the Aid flow from UN agencies (US$) in Middle East & North Africa (all income levels) and Aid flow from UN agencies (US$) in Lebanon?
Your answer should be compact. 5.83e+08. In the year 2012, what is the difference between the Aid flow from UN agencies (US$) in Middle East & North Africa (all income levels) and Aid flow from UN agencies (US$) in Syrian Arab Republic?
Provide a succinct answer. 6.13e+08. In the year 2012, what is the difference between the Aid flow from UN agencies (US$) in Middle income and Aid flow from UN agencies (US$) in Lebanon?
Keep it short and to the point. 5.83e+08. In the year 2012, what is the difference between the Aid flow from UN agencies (US$) in Middle income and Aid flow from UN agencies (US$) in Syrian Arab Republic?
Your answer should be very brief. 6.13e+08. In the year 2012, what is the difference between the Aid flow from UN agencies (US$) in Lebanon and Aid flow from UN agencies (US$) in Syrian Arab Republic?
Keep it short and to the point. 3.04e+07. In the year 2013, what is the difference between the Aid flow from UN agencies (US$) of Middle East & North Africa (all income levels) and Aid flow from UN agencies (US$) of Lebanon?
Your answer should be compact. 4.57e+08. In the year 2013, what is the difference between the Aid flow from UN agencies (US$) of Middle East & North Africa (all income levels) and Aid flow from UN agencies (US$) of Syrian Arab Republic?
Keep it short and to the point. 5.15e+08. In the year 2013, what is the difference between the Aid flow from UN agencies (US$) of Middle income and Aid flow from UN agencies (US$) of Lebanon?
Give a very brief answer. 4.57e+08. In the year 2013, what is the difference between the Aid flow from UN agencies (US$) of Middle income and Aid flow from UN agencies (US$) of Syrian Arab Republic?
Your response must be concise. 5.15e+08. In the year 2013, what is the difference between the Aid flow from UN agencies (US$) of Lebanon and Aid flow from UN agencies (US$) of Syrian Arab Republic?
Your answer should be compact. 5.80e+07. What is the ratio of the Aid flow from UN agencies (US$) in Middle East & North Africa (all income levels) in 2006 to that in 2007?
Your answer should be very brief. 0.96. What is the ratio of the Aid flow from UN agencies (US$) in Middle income in 2006 to that in 2007?
Ensure brevity in your answer.  0.96. What is the ratio of the Aid flow from UN agencies (US$) in Syrian Arab Republic in 2006 to that in 2007?
Keep it short and to the point. 0.91. What is the ratio of the Aid flow from UN agencies (US$) in Middle East & North Africa (all income levels) in 2006 to that in 2008?
Keep it short and to the point. 0.79. What is the ratio of the Aid flow from UN agencies (US$) in Middle income in 2006 to that in 2008?
Give a very brief answer. 0.79. What is the ratio of the Aid flow from UN agencies (US$) in Lebanon in 2006 to that in 2008?
Make the answer very short. 0.84. What is the ratio of the Aid flow from UN agencies (US$) of Syrian Arab Republic in 2006 to that in 2008?
Provide a succinct answer. 0.68. What is the ratio of the Aid flow from UN agencies (US$) in Middle East & North Africa (all income levels) in 2006 to that in 2009?
Provide a succinct answer. 0.79. What is the ratio of the Aid flow from UN agencies (US$) in Middle income in 2006 to that in 2009?
Ensure brevity in your answer.  0.79. What is the ratio of the Aid flow from UN agencies (US$) in Lebanon in 2006 to that in 2009?
Your answer should be compact. 0.77. What is the ratio of the Aid flow from UN agencies (US$) of Syrian Arab Republic in 2006 to that in 2009?
Keep it short and to the point. 0.67. What is the ratio of the Aid flow from UN agencies (US$) of Middle East & North Africa (all income levels) in 2006 to that in 2010?
Offer a terse response. 0.68. What is the ratio of the Aid flow from UN agencies (US$) in Middle income in 2006 to that in 2010?
Provide a succinct answer. 0.68. What is the ratio of the Aid flow from UN agencies (US$) of Lebanon in 2006 to that in 2010?
Your response must be concise. 0.72. What is the ratio of the Aid flow from UN agencies (US$) in Syrian Arab Republic in 2006 to that in 2010?
Provide a short and direct response. 0.63. What is the ratio of the Aid flow from UN agencies (US$) in Middle East & North Africa (all income levels) in 2006 to that in 2011?
Offer a very short reply. 0.61. What is the ratio of the Aid flow from UN agencies (US$) in Middle income in 2006 to that in 2011?
Give a very brief answer. 0.61. What is the ratio of the Aid flow from UN agencies (US$) in Lebanon in 2006 to that in 2011?
Ensure brevity in your answer.  0.67. What is the ratio of the Aid flow from UN agencies (US$) of Syrian Arab Republic in 2006 to that in 2011?
Offer a very short reply. 0.56. What is the ratio of the Aid flow from UN agencies (US$) in Middle East & North Africa (all income levels) in 2006 to that in 2012?
Your response must be concise. 0.56. What is the ratio of the Aid flow from UN agencies (US$) in Middle income in 2006 to that in 2012?
Make the answer very short. 0.56. What is the ratio of the Aid flow from UN agencies (US$) of Lebanon in 2006 to that in 2012?
Offer a very short reply. 0.61. What is the ratio of the Aid flow from UN agencies (US$) of Syrian Arab Republic in 2006 to that in 2012?
Offer a very short reply. 0.52. What is the ratio of the Aid flow from UN agencies (US$) in Middle East & North Africa (all income levels) in 2006 to that in 2013?
Your answer should be compact. 0.69. What is the ratio of the Aid flow from UN agencies (US$) in Middle income in 2006 to that in 2013?
Your response must be concise. 0.69. What is the ratio of the Aid flow from UN agencies (US$) in Lebanon in 2006 to that in 2013?
Give a very brief answer. 0.63. What is the ratio of the Aid flow from UN agencies (US$) in Syrian Arab Republic in 2006 to that in 2013?
Offer a very short reply. 1.18. What is the ratio of the Aid flow from UN agencies (US$) in Middle East & North Africa (all income levels) in 2007 to that in 2008?
Offer a very short reply. 0.82. What is the ratio of the Aid flow from UN agencies (US$) of Middle income in 2007 to that in 2008?
Offer a terse response. 0.82. What is the ratio of the Aid flow from UN agencies (US$) in Lebanon in 2007 to that in 2008?
Offer a very short reply. 0.85. What is the ratio of the Aid flow from UN agencies (US$) of Syrian Arab Republic in 2007 to that in 2008?
Give a very brief answer. 0.75. What is the ratio of the Aid flow from UN agencies (US$) of Middle East & North Africa (all income levels) in 2007 to that in 2009?
Make the answer very short. 0.82. What is the ratio of the Aid flow from UN agencies (US$) of Middle income in 2007 to that in 2009?
Provide a succinct answer. 0.82. What is the ratio of the Aid flow from UN agencies (US$) in Lebanon in 2007 to that in 2009?
Your answer should be very brief. 0.77. What is the ratio of the Aid flow from UN agencies (US$) in Syrian Arab Republic in 2007 to that in 2009?
Your answer should be compact. 0.74. What is the ratio of the Aid flow from UN agencies (US$) of Middle East & North Africa (all income levels) in 2007 to that in 2010?
Offer a very short reply. 0.71. What is the ratio of the Aid flow from UN agencies (US$) of Middle income in 2007 to that in 2010?
Your answer should be very brief. 0.71. What is the ratio of the Aid flow from UN agencies (US$) in Lebanon in 2007 to that in 2010?
Make the answer very short. 0.73. What is the ratio of the Aid flow from UN agencies (US$) of Syrian Arab Republic in 2007 to that in 2010?
Your answer should be compact. 0.69. What is the ratio of the Aid flow from UN agencies (US$) of Middle East & North Africa (all income levels) in 2007 to that in 2011?
Offer a terse response. 0.64. What is the ratio of the Aid flow from UN agencies (US$) of Middle income in 2007 to that in 2011?
Offer a very short reply. 0.64. What is the ratio of the Aid flow from UN agencies (US$) of Lebanon in 2007 to that in 2011?
Offer a very short reply. 0.68. What is the ratio of the Aid flow from UN agencies (US$) in Syrian Arab Republic in 2007 to that in 2011?
Keep it short and to the point. 0.61. What is the ratio of the Aid flow from UN agencies (US$) of Middle East & North Africa (all income levels) in 2007 to that in 2012?
Offer a terse response. 0.58. What is the ratio of the Aid flow from UN agencies (US$) of Middle income in 2007 to that in 2012?
Your answer should be very brief. 0.58. What is the ratio of the Aid flow from UN agencies (US$) in Lebanon in 2007 to that in 2012?
Keep it short and to the point. 0.61. What is the ratio of the Aid flow from UN agencies (US$) of Syrian Arab Republic in 2007 to that in 2012?
Offer a very short reply. 0.57. What is the ratio of the Aid flow from UN agencies (US$) of Middle East & North Africa (all income levels) in 2007 to that in 2013?
Keep it short and to the point. 0.72. What is the ratio of the Aid flow from UN agencies (US$) of Middle income in 2007 to that in 2013?
Make the answer very short. 0.72. What is the ratio of the Aid flow from UN agencies (US$) of Lebanon in 2007 to that in 2013?
Give a very brief answer. 0.63. What is the ratio of the Aid flow from UN agencies (US$) of Syrian Arab Republic in 2007 to that in 2013?
Offer a very short reply. 1.29. What is the ratio of the Aid flow from UN agencies (US$) in Middle East & North Africa (all income levels) in 2008 to that in 2009?
Provide a short and direct response. 1. What is the ratio of the Aid flow from UN agencies (US$) in Lebanon in 2008 to that in 2009?
Your response must be concise. 0.91. What is the ratio of the Aid flow from UN agencies (US$) in Syrian Arab Republic in 2008 to that in 2009?
Your response must be concise. 0.99. What is the ratio of the Aid flow from UN agencies (US$) of Middle East & North Africa (all income levels) in 2008 to that in 2010?
Ensure brevity in your answer.  0.87. What is the ratio of the Aid flow from UN agencies (US$) in Middle income in 2008 to that in 2010?
Keep it short and to the point. 0.87. What is the ratio of the Aid flow from UN agencies (US$) of Lebanon in 2008 to that in 2010?
Your answer should be very brief. 0.86. What is the ratio of the Aid flow from UN agencies (US$) of Syrian Arab Republic in 2008 to that in 2010?
Make the answer very short. 0.92. What is the ratio of the Aid flow from UN agencies (US$) of Middle East & North Africa (all income levels) in 2008 to that in 2011?
Provide a succinct answer. 0.78. What is the ratio of the Aid flow from UN agencies (US$) in Middle income in 2008 to that in 2011?
Your answer should be very brief. 0.78. What is the ratio of the Aid flow from UN agencies (US$) in Lebanon in 2008 to that in 2011?
Ensure brevity in your answer.  0.79. What is the ratio of the Aid flow from UN agencies (US$) in Syrian Arab Republic in 2008 to that in 2011?
Offer a very short reply. 0.82. What is the ratio of the Aid flow from UN agencies (US$) of Middle East & North Africa (all income levels) in 2008 to that in 2012?
Your response must be concise. 0.71. What is the ratio of the Aid flow from UN agencies (US$) of Middle income in 2008 to that in 2012?
Make the answer very short. 0.71. What is the ratio of the Aid flow from UN agencies (US$) in Lebanon in 2008 to that in 2012?
Ensure brevity in your answer.  0.72. What is the ratio of the Aid flow from UN agencies (US$) of Syrian Arab Republic in 2008 to that in 2012?
Your response must be concise. 0.77. What is the ratio of the Aid flow from UN agencies (US$) of Middle East & North Africa (all income levels) in 2008 to that in 2013?
Offer a terse response. 0.88. What is the ratio of the Aid flow from UN agencies (US$) of Middle income in 2008 to that in 2013?
Provide a short and direct response. 0.88. What is the ratio of the Aid flow from UN agencies (US$) in Lebanon in 2008 to that in 2013?
Your answer should be compact. 0.74. What is the ratio of the Aid flow from UN agencies (US$) in Syrian Arab Republic in 2008 to that in 2013?
Your answer should be very brief. 1.73. What is the ratio of the Aid flow from UN agencies (US$) in Middle East & North Africa (all income levels) in 2009 to that in 2010?
Keep it short and to the point. 0.87. What is the ratio of the Aid flow from UN agencies (US$) of Middle income in 2009 to that in 2010?
Provide a succinct answer. 0.87. What is the ratio of the Aid flow from UN agencies (US$) in Lebanon in 2009 to that in 2010?
Your answer should be compact. 0.94. What is the ratio of the Aid flow from UN agencies (US$) in Syrian Arab Republic in 2009 to that in 2010?
Your answer should be compact. 0.94. What is the ratio of the Aid flow from UN agencies (US$) of Lebanon in 2009 to that in 2011?
Your response must be concise. 0.87. What is the ratio of the Aid flow from UN agencies (US$) in Syrian Arab Republic in 2009 to that in 2011?
Keep it short and to the point. 0.83. What is the ratio of the Aid flow from UN agencies (US$) of Middle East & North Africa (all income levels) in 2009 to that in 2012?
Offer a terse response. 0.71. What is the ratio of the Aid flow from UN agencies (US$) of Middle income in 2009 to that in 2012?
Your answer should be very brief. 0.71. What is the ratio of the Aid flow from UN agencies (US$) of Lebanon in 2009 to that in 2012?
Ensure brevity in your answer.  0.79. What is the ratio of the Aid flow from UN agencies (US$) of Syrian Arab Republic in 2009 to that in 2012?
Your response must be concise. 0.78. What is the ratio of the Aid flow from UN agencies (US$) in Middle East & North Africa (all income levels) in 2009 to that in 2013?
Give a very brief answer. 0.88. What is the ratio of the Aid flow from UN agencies (US$) of Middle income in 2009 to that in 2013?
Your response must be concise. 0.88. What is the ratio of the Aid flow from UN agencies (US$) of Lebanon in 2009 to that in 2013?
Offer a terse response. 0.82. What is the ratio of the Aid flow from UN agencies (US$) in Syrian Arab Republic in 2009 to that in 2013?
Offer a very short reply. 1.75. What is the ratio of the Aid flow from UN agencies (US$) in Middle East & North Africa (all income levels) in 2010 to that in 2011?
Your answer should be compact. 0.9. What is the ratio of the Aid flow from UN agencies (US$) of Middle income in 2010 to that in 2011?
Ensure brevity in your answer.  0.9. What is the ratio of the Aid flow from UN agencies (US$) of Lebanon in 2010 to that in 2011?
Provide a succinct answer. 0.93. What is the ratio of the Aid flow from UN agencies (US$) in Syrian Arab Republic in 2010 to that in 2011?
Offer a terse response. 0.88. What is the ratio of the Aid flow from UN agencies (US$) of Middle East & North Africa (all income levels) in 2010 to that in 2012?
Offer a terse response. 0.82. What is the ratio of the Aid flow from UN agencies (US$) in Middle income in 2010 to that in 2012?
Ensure brevity in your answer.  0.82. What is the ratio of the Aid flow from UN agencies (US$) in Lebanon in 2010 to that in 2012?
Provide a short and direct response. 0.84. What is the ratio of the Aid flow from UN agencies (US$) of Syrian Arab Republic in 2010 to that in 2012?
Your answer should be compact. 0.83. What is the ratio of the Aid flow from UN agencies (US$) in Middle East & North Africa (all income levels) in 2010 to that in 2013?
Offer a terse response. 1.01. What is the ratio of the Aid flow from UN agencies (US$) in Middle income in 2010 to that in 2013?
Your response must be concise. 1.01. What is the ratio of the Aid flow from UN agencies (US$) of Lebanon in 2010 to that in 2013?
Offer a terse response. 0.86. What is the ratio of the Aid flow from UN agencies (US$) of Syrian Arab Republic in 2010 to that in 2013?
Offer a very short reply. 1.87. What is the ratio of the Aid flow from UN agencies (US$) in Middle East & North Africa (all income levels) in 2011 to that in 2012?
Provide a succinct answer. 0.91. What is the ratio of the Aid flow from UN agencies (US$) in Middle income in 2011 to that in 2012?
Provide a succinct answer. 0.91. What is the ratio of the Aid flow from UN agencies (US$) in Lebanon in 2011 to that in 2012?
Provide a short and direct response. 0.9. What is the ratio of the Aid flow from UN agencies (US$) in Syrian Arab Republic in 2011 to that in 2012?
Your answer should be very brief. 0.94. What is the ratio of the Aid flow from UN agencies (US$) of Middle East & North Africa (all income levels) in 2011 to that in 2013?
Your answer should be very brief. 1.13. What is the ratio of the Aid flow from UN agencies (US$) of Middle income in 2011 to that in 2013?
Keep it short and to the point. 1.13. What is the ratio of the Aid flow from UN agencies (US$) in Lebanon in 2011 to that in 2013?
Provide a succinct answer. 0.93. What is the ratio of the Aid flow from UN agencies (US$) of Syrian Arab Republic in 2011 to that in 2013?
Offer a very short reply. 2.11. What is the ratio of the Aid flow from UN agencies (US$) of Middle East & North Africa (all income levels) in 2012 to that in 2013?
Provide a short and direct response. 1.24. What is the ratio of the Aid flow from UN agencies (US$) in Middle income in 2012 to that in 2013?
Make the answer very short. 1.24. What is the ratio of the Aid flow from UN agencies (US$) in Lebanon in 2012 to that in 2013?
Your response must be concise. 1.03. What is the ratio of the Aid flow from UN agencies (US$) in Syrian Arab Republic in 2012 to that in 2013?
Your response must be concise. 2.25. What is the difference between the highest and the second highest Aid flow from UN agencies (US$) of Middle East & North Africa (all income levels)?
Provide a short and direct response. 5.94e+07. What is the difference between the highest and the second highest Aid flow from UN agencies (US$) in Middle income?
Your answer should be compact. 5.94e+07. What is the difference between the highest and the second highest Aid flow from UN agencies (US$) in Lebanon?
Provide a short and direct response. 2.58e+06. What is the difference between the highest and the second highest Aid flow from UN agencies (US$) in Syrian Arab Republic?
Provide a succinct answer. 3.35e+06. What is the difference between the highest and the lowest Aid flow from UN agencies (US$) in Middle East & North Africa (all income levels)?
Offer a terse response. 2.96e+08. What is the difference between the highest and the lowest Aid flow from UN agencies (US$) of Middle income?
Provide a succinct answer. 2.96e+08. What is the difference between the highest and the lowest Aid flow from UN agencies (US$) of Lebanon?
Provide a succinct answer. 3.33e+07. What is the difference between the highest and the lowest Aid flow from UN agencies (US$) in Syrian Arab Republic?
Your answer should be very brief. 3.02e+07. 